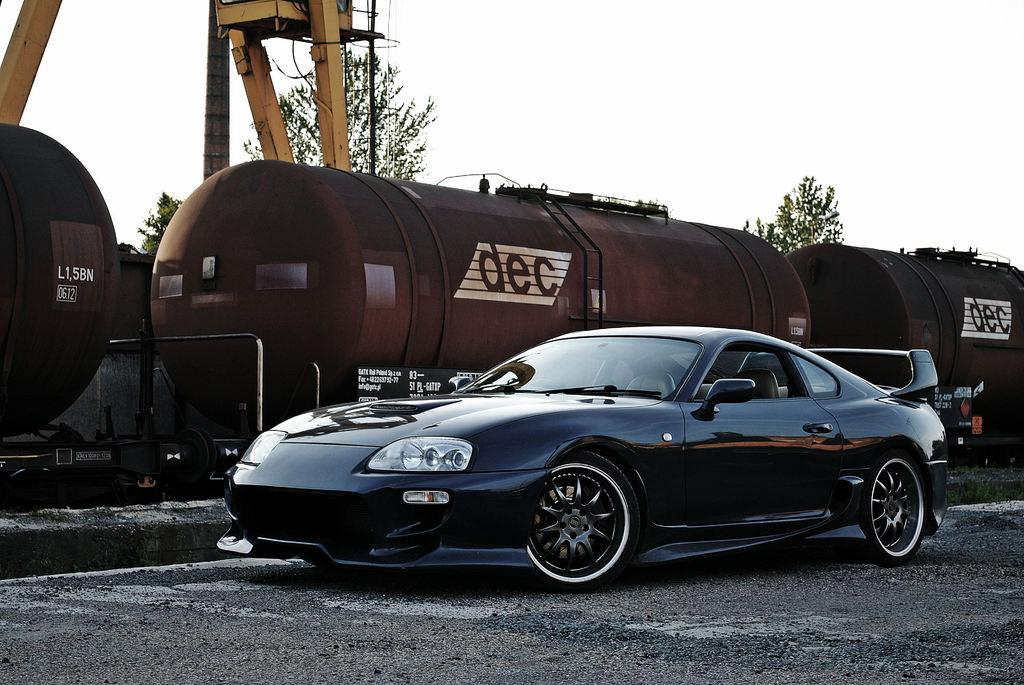What type of vehicle is on the ground in the image? There is a car on the ground in the image. What other mode of transportation can be seen in the image? There is a train in the image. What structures are present in the image? There are wooden poles in the image. What type of natural elements are in the image? There are trees in the image. Can you describe any unspecified objects in the image? There are some unspecified objects in the image. What can be seen in the background of the image? The sky is visible in the background of the image. How many cows are visible in the image? There are no cows present in the image. What color are the pig's toes in the image? There are no pigs or references to toes in the image. 